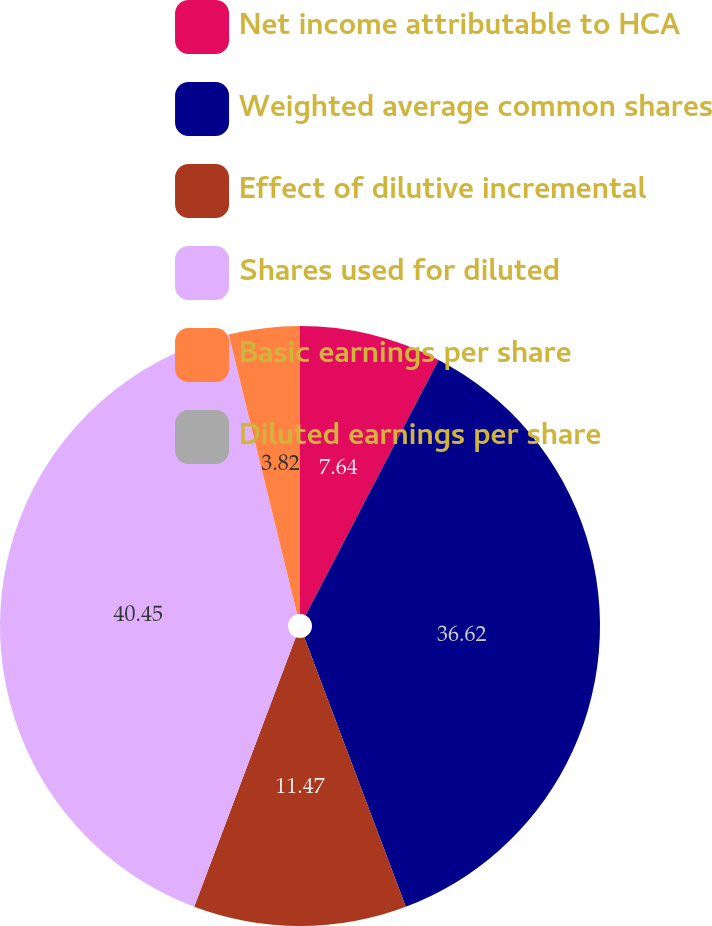<chart> <loc_0><loc_0><loc_500><loc_500><pie_chart><fcel>Net income attributable to HCA<fcel>Weighted average common shares<fcel>Effect of dilutive incremental<fcel>Shares used for diluted<fcel>Basic earnings per share<fcel>Diluted earnings per share<nl><fcel>7.64%<fcel>36.62%<fcel>11.47%<fcel>40.44%<fcel>3.82%<fcel>0.0%<nl></chart> 